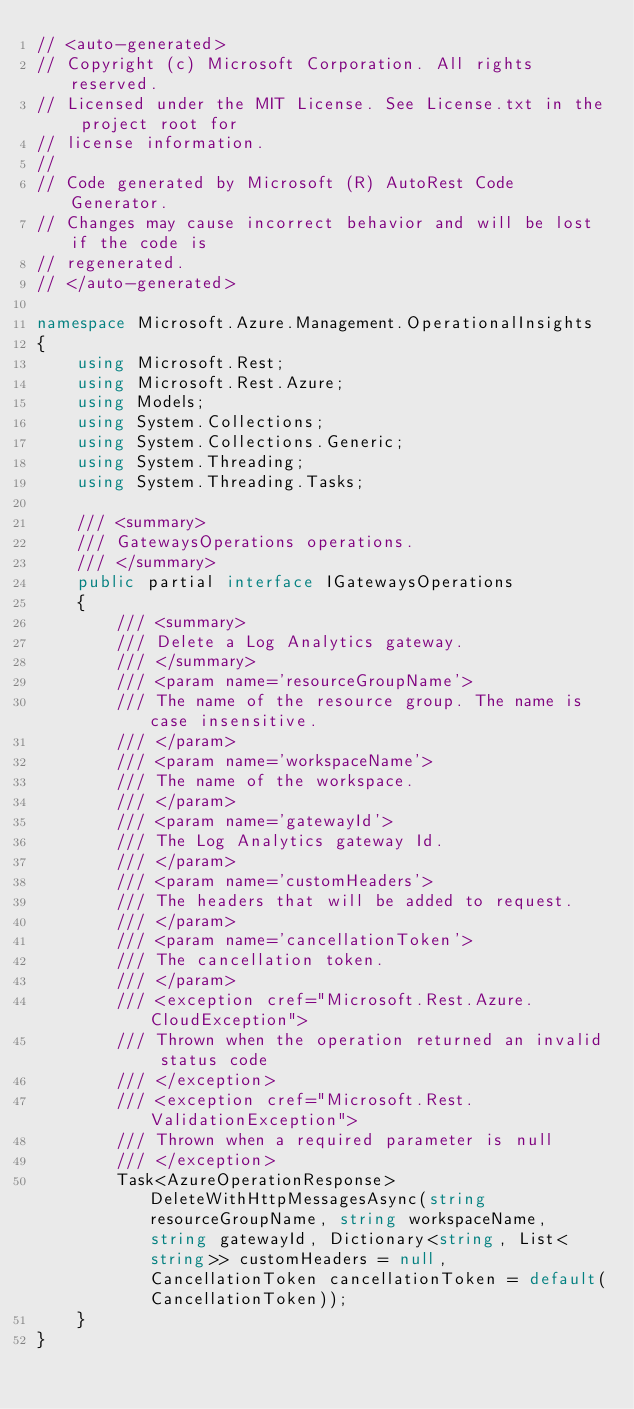<code> <loc_0><loc_0><loc_500><loc_500><_C#_>// <auto-generated>
// Copyright (c) Microsoft Corporation. All rights reserved.
// Licensed under the MIT License. See License.txt in the project root for
// license information.
//
// Code generated by Microsoft (R) AutoRest Code Generator.
// Changes may cause incorrect behavior and will be lost if the code is
// regenerated.
// </auto-generated>

namespace Microsoft.Azure.Management.OperationalInsights
{
    using Microsoft.Rest;
    using Microsoft.Rest.Azure;
    using Models;
    using System.Collections;
    using System.Collections.Generic;
    using System.Threading;
    using System.Threading.Tasks;

    /// <summary>
    /// GatewaysOperations operations.
    /// </summary>
    public partial interface IGatewaysOperations
    {
        /// <summary>
        /// Delete a Log Analytics gateway.
        /// </summary>
        /// <param name='resourceGroupName'>
        /// The name of the resource group. The name is case insensitive.
        /// </param>
        /// <param name='workspaceName'>
        /// The name of the workspace.
        /// </param>
        /// <param name='gatewayId'>
        /// The Log Analytics gateway Id.
        /// </param>
        /// <param name='customHeaders'>
        /// The headers that will be added to request.
        /// </param>
        /// <param name='cancellationToken'>
        /// The cancellation token.
        /// </param>
        /// <exception cref="Microsoft.Rest.Azure.CloudException">
        /// Thrown when the operation returned an invalid status code
        /// </exception>
        /// <exception cref="Microsoft.Rest.ValidationException">
        /// Thrown when a required parameter is null
        /// </exception>
        Task<AzureOperationResponse> DeleteWithHttpMessagesAsync(string resourceGroupName, string workspaceName, string gatewayId, Dictionary<string, List<string>> customHeaders = null, CancellationToken cancellationToken = default(CancellationToken));
    }
}
</code> 